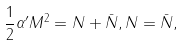<formula> <loc_0><loc_0><loc_500><loc_500>\frac { 1 } { 2 } \alpha ^ { \prime } M ^ { 2 } = N + \bar { N } , N = \bar { N } ,</formula> 